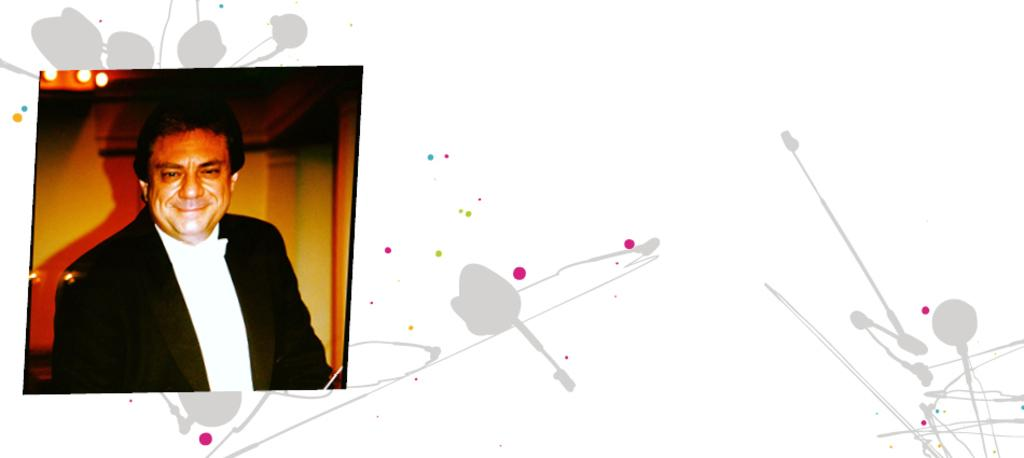What is the main subject of the image? There is a photograph of a person in the image. What is the person wearing in the image? The person is wearing a black suit and a white shirt. Can you describe any editing or alterations in the image? The image appears to be edited. What is the current weather like in the image? The image is a photograph of a person wearing a black suit and a white shirt, and there is no information about the weather in the image. 